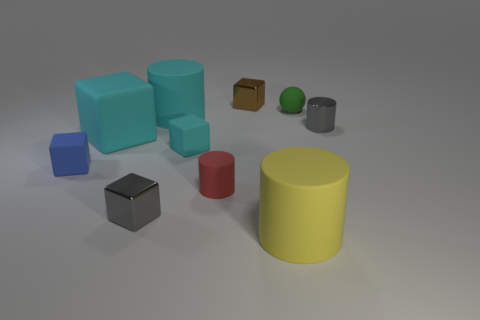Does the tiny brown block have the same material as the green thing behind the tiny blue cube?
Your response must be concise. No. How many other things are there of the same shape as the yellow rubber thing?
Provide a short and direct response. 3. There is a tiny metallic cylinder; is its color the same as the small metallic cube that is in front of the tiny green matte thing?
Your response must be concise. Yes. What is the shape of the small gray thing that is left of the shiny block that is behind the gray metal cylinder?
Offer a very short reply. Cube. There is a rubber cylinder that is the same color as the large rubber cube; what size is it?
Offer a terse response. Large. Do the tiny metallic object that is in front of the blue cube and the yellow rubber thing have the same shape?
Give a very brief answer. No. Is the number of large matte cylinders that are left of the yellow matte cylinder greater than the number of small brown things that are behind the tiny brown metal block?
Keep it short and to the point. Yes. How many brown metallic blocks are in front of the big cylinder in front of the small gray cylinder?
Ensure brevity in your answer.  0. There is a block that is the same color as the shiny cylinder; what is its material?
Provide a short and direct response. Metal. What number of other objects are there of the same color as the metal cylinder?
Make the answer very short. 1. 